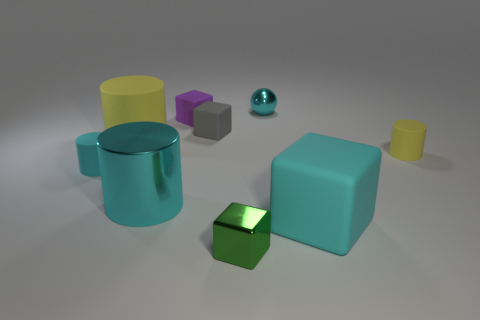Add 1 tiny blocks. How many objects exist? 10 Subtract all cyan blocks. How many blocks are left? 3 Subtract all green blocks. How many blocks are left? 3 Subtract all cylinders. How many objects are left? 5 Subtract 4 cylinders. How many cylinders are left? 0 Subtract all metallic blocks. Subtract all small metallic blocks. How many objects are left? 7 Add 3 big yellow things. How many big yellow things are left? 4 Add 8 yellow metallic blocks. How many yellow metallic blocks exist? 8 Subtract 0 red blocks. How many objects are left? 9 Subtract all purple cubes. Subtract all gray balls. How many cubes are left? 3 